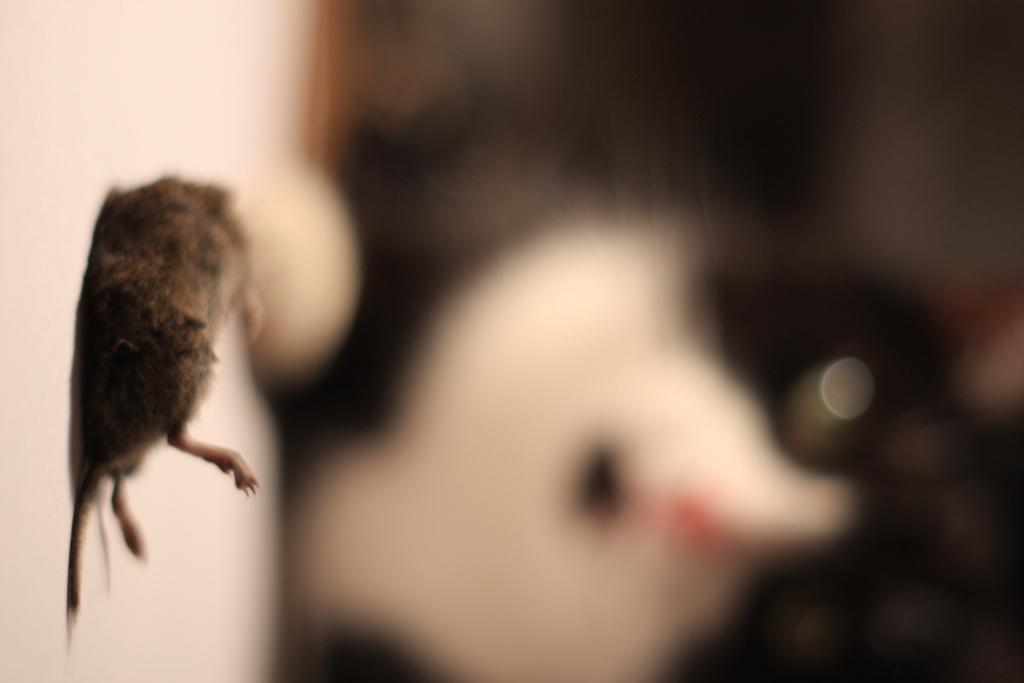What type of creature is in the image? There is an animal in the image. Where is the animal located? The animal is on the floor. Can you describe the background of the image? The background of the image is blurry. How many boys are talking in the image? There are no boys present in the image, and no talking is depicted. 